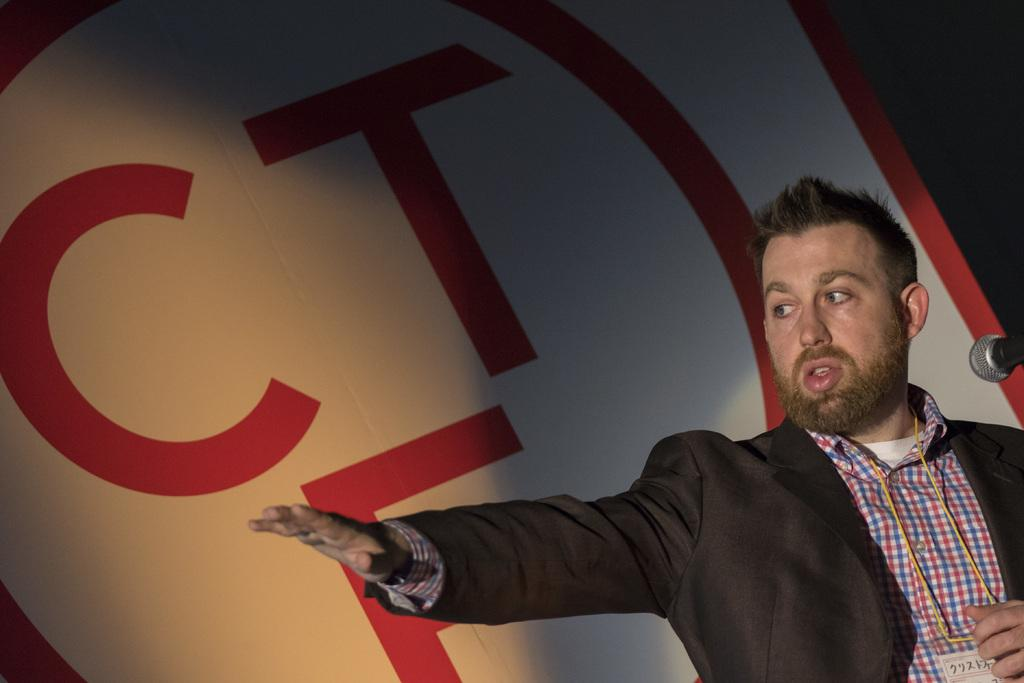Who or what is the main subject in the image? There is a person in the image. What is the person doing in the image? The person is raising their hand. What object is in front of the person? There is a microphone in front of the person. What can be seen on the wall behind the person? There is text on the wall behind the person. How many bikes are parked next to the person in the image? There are no bikes present in the image. What time of day is it in the image, considering the presence of morning light? The image does not provide any information about the time of day, as there is no mention of morning light or any other time-related cues. 